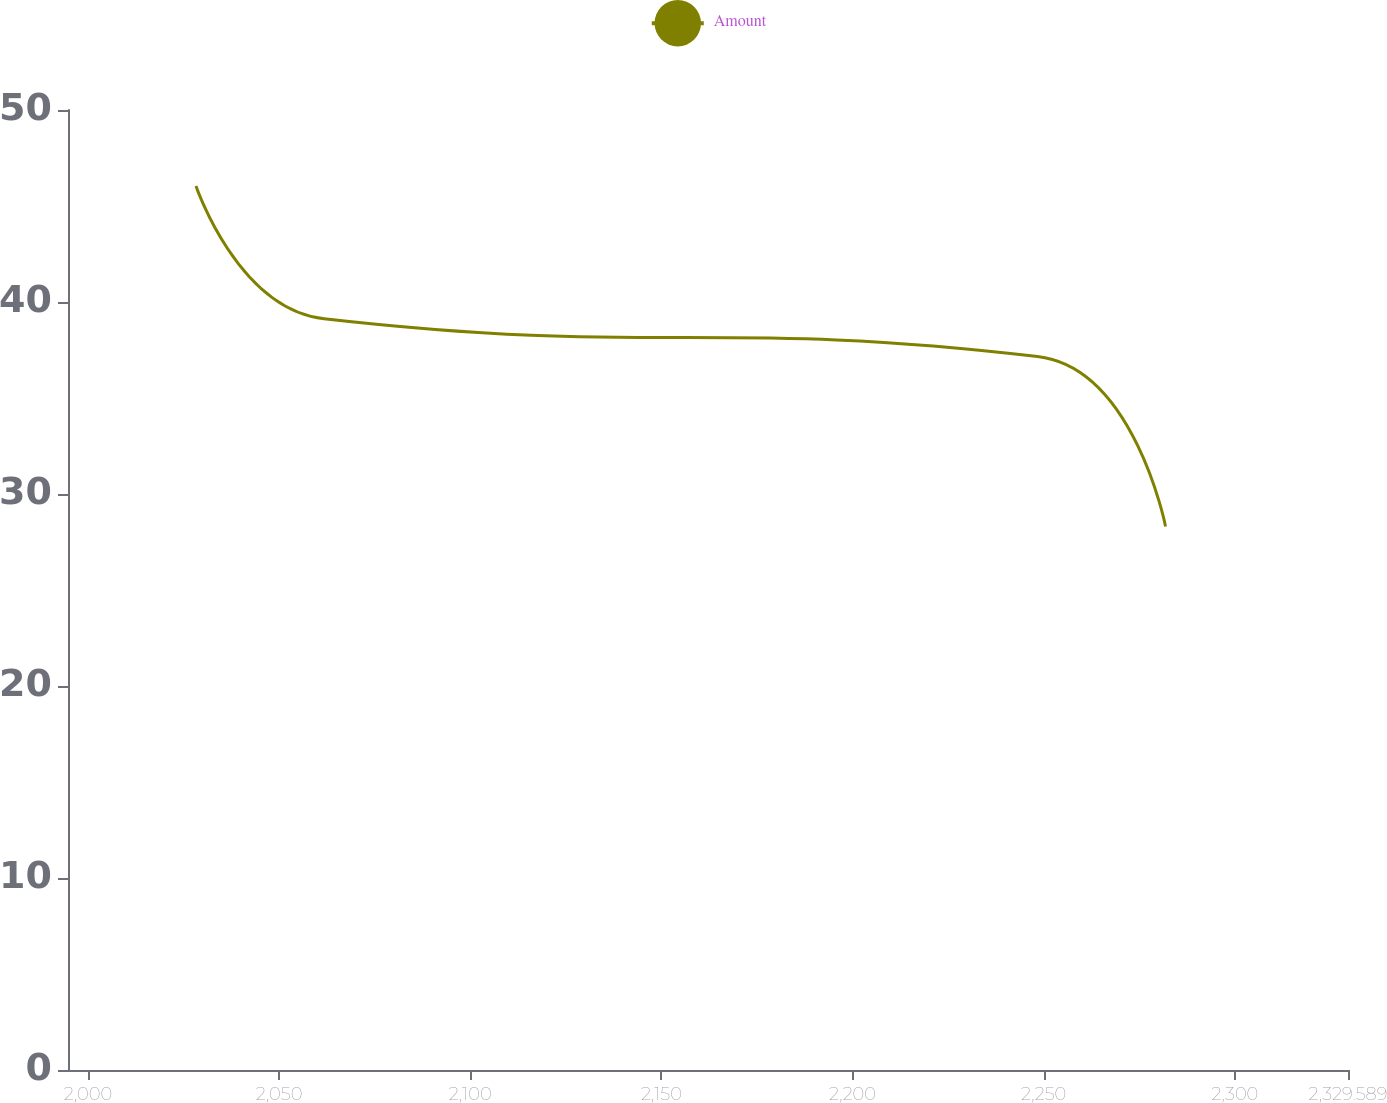Convert chart. <chart><loc_0><loc_0><loc_500><loc_500><line_chart><ecel><fcel>Amount<nl><fcel>2028.26<fcel>46.04<nl><fcel>2061.74<fcel>39.13<nl><fcel>2248.38<fcel>37.16<nl><fcel>2281.86<fcel>28.31<nl><fcel>2363.07<fcel>26.34<nl></chart> 